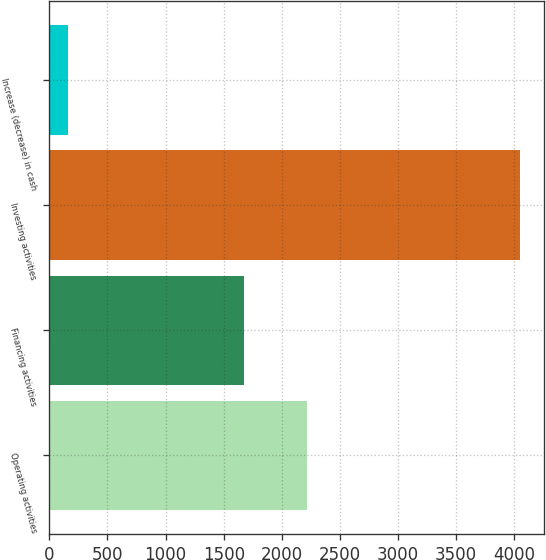Convert chart. <chart><loc_0><loc_0><loc_500><loc_500><bar_chart><fcel>Operating activities<fcel>Financing activities<fcel>Investing activities<fcel>Increase (decrease) in cash<nl><fcel>2217<fcel>1677<fcel>4052<fcel>158<nl></chart> 